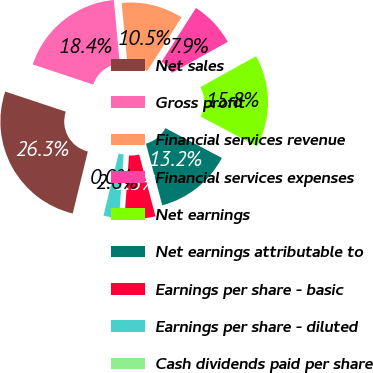Convert chart. <chart><loc_0><loc_0><loc_500><loc_500><pie_chart><fcel>Net sales<fcel>Gross profit<fcel>Financial services revenue<fcel>Financial services expenses<fcel>Net earnings<fcel>Net earnings attributable to<fcel>Earnings per share - basic<fcel>Earnings per share - diluted<fcel>Cash dividends paid per share<nl><fcel>26.3%<fcel>18.41%<fcel>10.53%<fcel>7.9%<fcel>15.78%<fcel>13.16%<fcel>5.27%<fcel>2.64%<fcel>0.01%<nl></chart> 